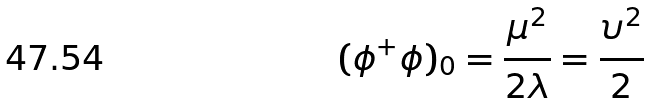Convert formula to latex. <formula><loc_0><loc_0><loc_500><loc_500>( \phi ^ { + } \phi ) _ { 0 } = \frac { \mu ^ { 2 } } { 2 \lambda } = \frac { \upsilon ^ { 2 } } { 2 }</formula> 